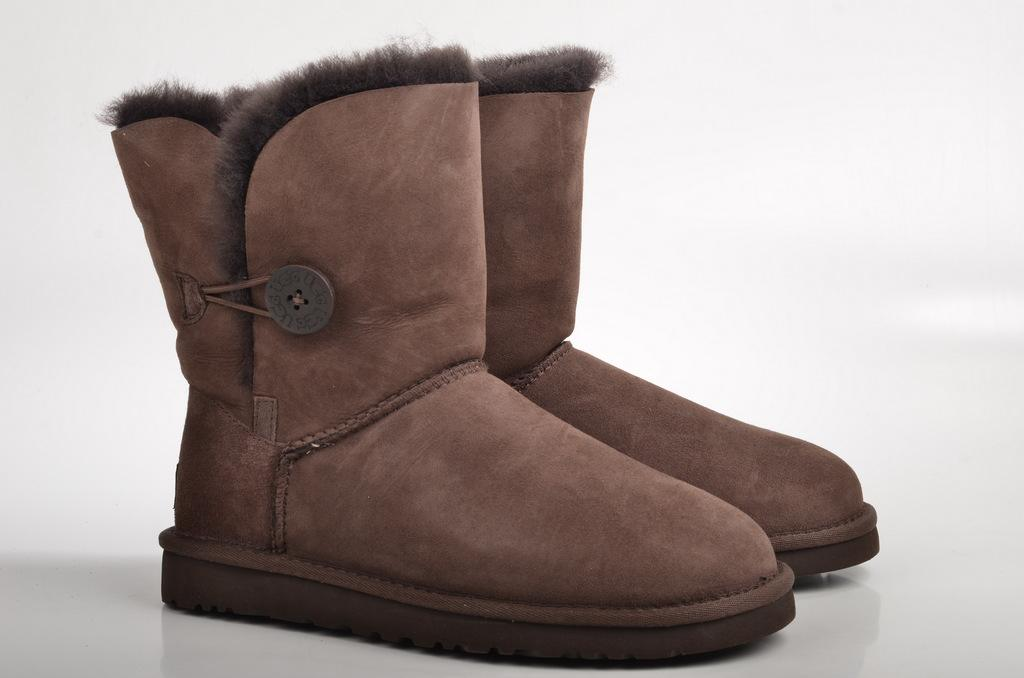What type of footwear is present in the image? There are boots in the image. What color is the background of the image? The background of the image is white in color. Can you see a rabbit hopping around the boots in the image? There is no rabbit present in the image. How many fingers can be seen interacting with the boots in the image? There is no indication of fingers or any hand interacting with the boots in the image. 